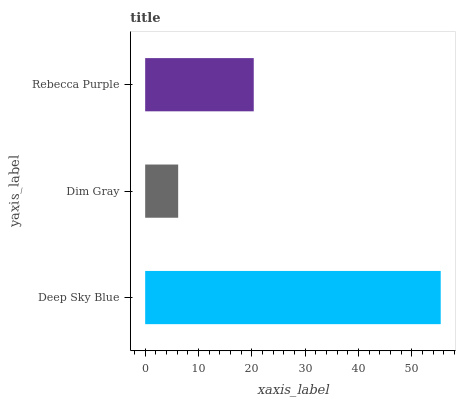Is Dim Gray the minimum?
Answer yes or no. Yes. Is Deep Sky Blue the maximum?
Answer yes or no. Yes. Is Rebecca Purple the minimum?
Answer yes or no. No. Is Rebecca Purple the maximum?
Answer yes or no. No. Is Rebecca Purple greater than Dim Gray?
Answer yes or no. Yes. Is Dim Gray less than Rebecca Purple?
Answer yes or no. Yes. Is Dim Gray greater than Rebecca Purple?
Answer yes or no. No. Is Rebecca Purple less than Dim Gray?
Answer yes or no. No. Is Rebecca Purple the high median?
Answer yes or no. Yes. Is Rebecca Purple the low median?
Answer yes or no. Yes. Is Dim Gray the high median?
Answer yes or no. No. Is Deep Sky Blue the low median?
Answer yes or no. No. 